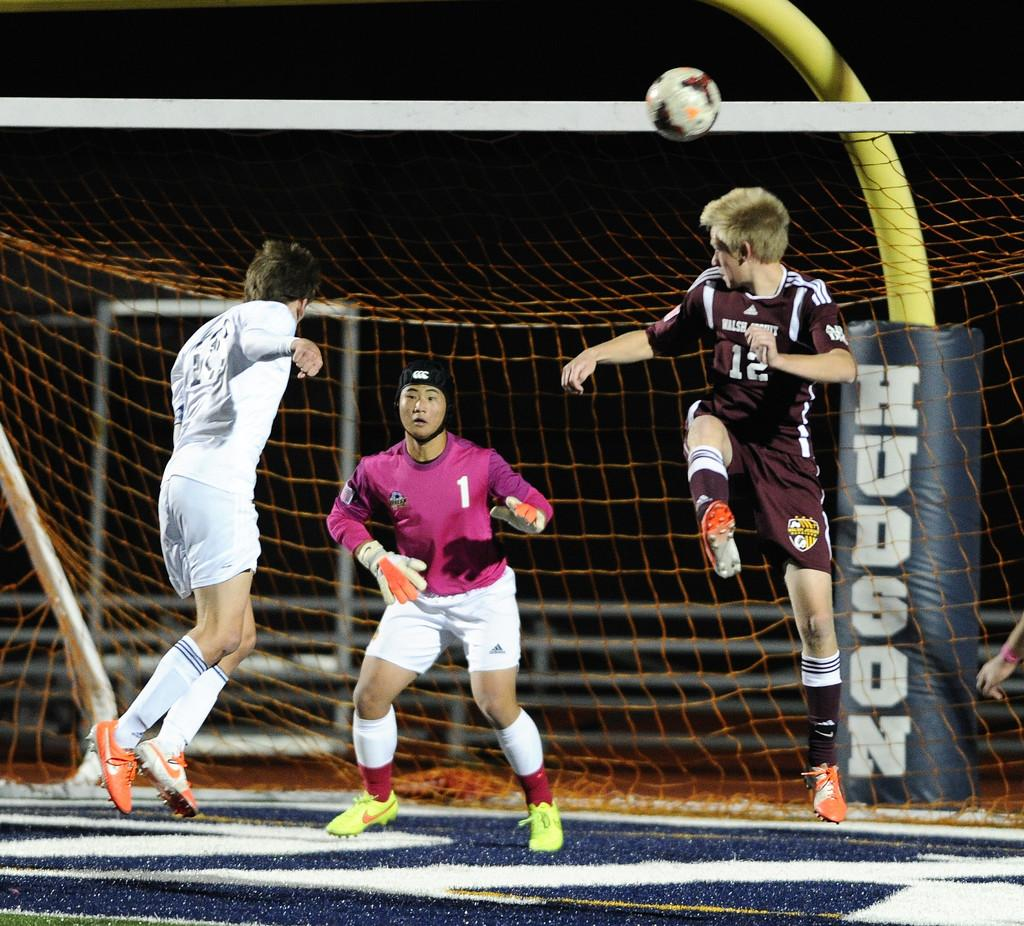<image>
Write a terse but informative summary of the picture. Players playing a sport in front of a sign that says Hudson. 